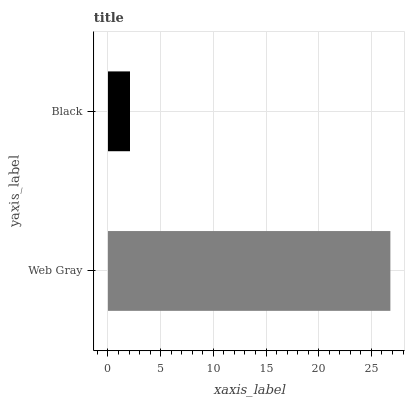Is Black the minimum?
Answer yes or no. Yes. Is Web Gray the maximum?
Answer yes or no. Yes. Is Black the maximum?
Answer yes or no. No. Is Web Gray greater than Black?
Answer yes or no. Yes. Is Black less than Web Gray?
Answer yes or no. Yes. Is Black greater than Web Gray?
Answer yes or no. No. Is Web Gray less than Black?
Answer yes or no. No. Is Web Gray the high median?
Answer yes or no. Yes. Is Black the low median?
Answer yes or no. Yes. Is Black the high median?
Answer yes or no. No. Is Web Gray the low median?
Answer yes or no. No. 